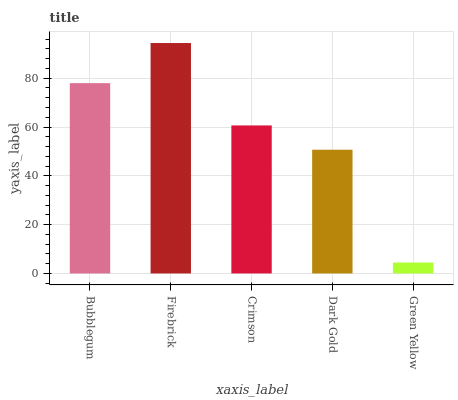Is Green Yellow the minimum?
Answer yes or no. Yes. Is Firebrick the maximum?
Answer yes or no. Yes. Is Crimson the minimum?
Answer yes or no. No. Is Crimson the maximum?
Answer yes or no. No. Is Firebrick greater than Crimson?
Answer yes or no. Yes. Is Crimson less than Firebrick?
Answer yes or no. Yes. Is Crimson greater than Firebrick?
Answer yes or no. No. Is Firebrick less than Crimson?
Answer yes or no. No. Is Crimson the high median?
Answer yes or no. Yes. Is Crimson the low median?
Answer yes or no. Yes. Is Dark Gold the high median?
Answer yes or no. No. Is Green Yellow the low median?
Answer yes or no. No. 